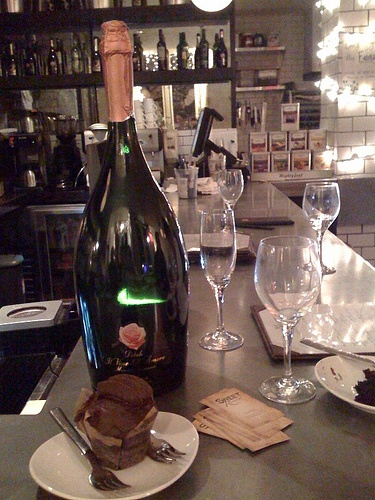Describe the objects in this image and their specific colors. I can see bottle in black, brown, maroon, and gray tones, wine glass in black, gray, darkgray, tan, and lightgray tones, cake in black, maroon, and brown tones, wine glass in black, gray, and darkgray tones, and bottle in black and gray tones in this image. 